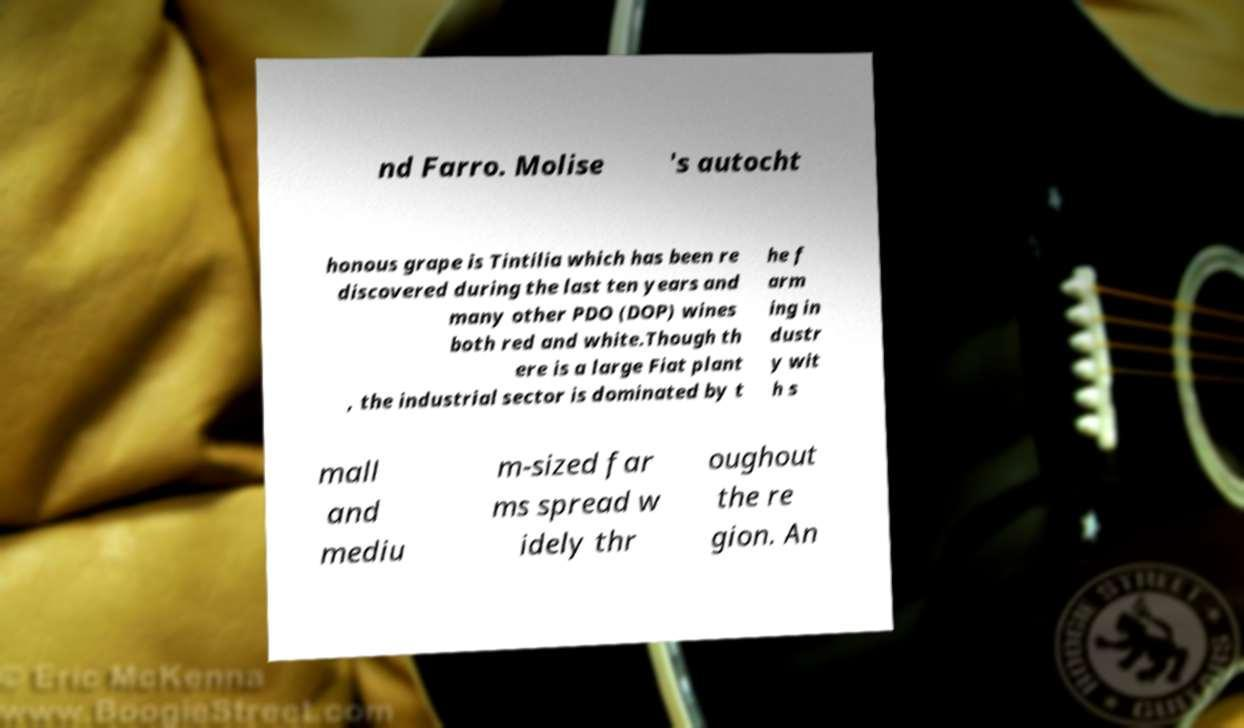For documentation purposes, I need the text within this image transcribed. Could you provide that? nd Farro. Molise 's autocht honous grape is Tintilia which has been re discovered during the last ten years and many other PDO (DOP) wines both red and white.Though th ere is a large Fiat plant , the industrial sector is dominated by t he f arm ing in dustr y wit h s mall and mediu m-sized far ms spread w idely thr oughout the re gion. An 